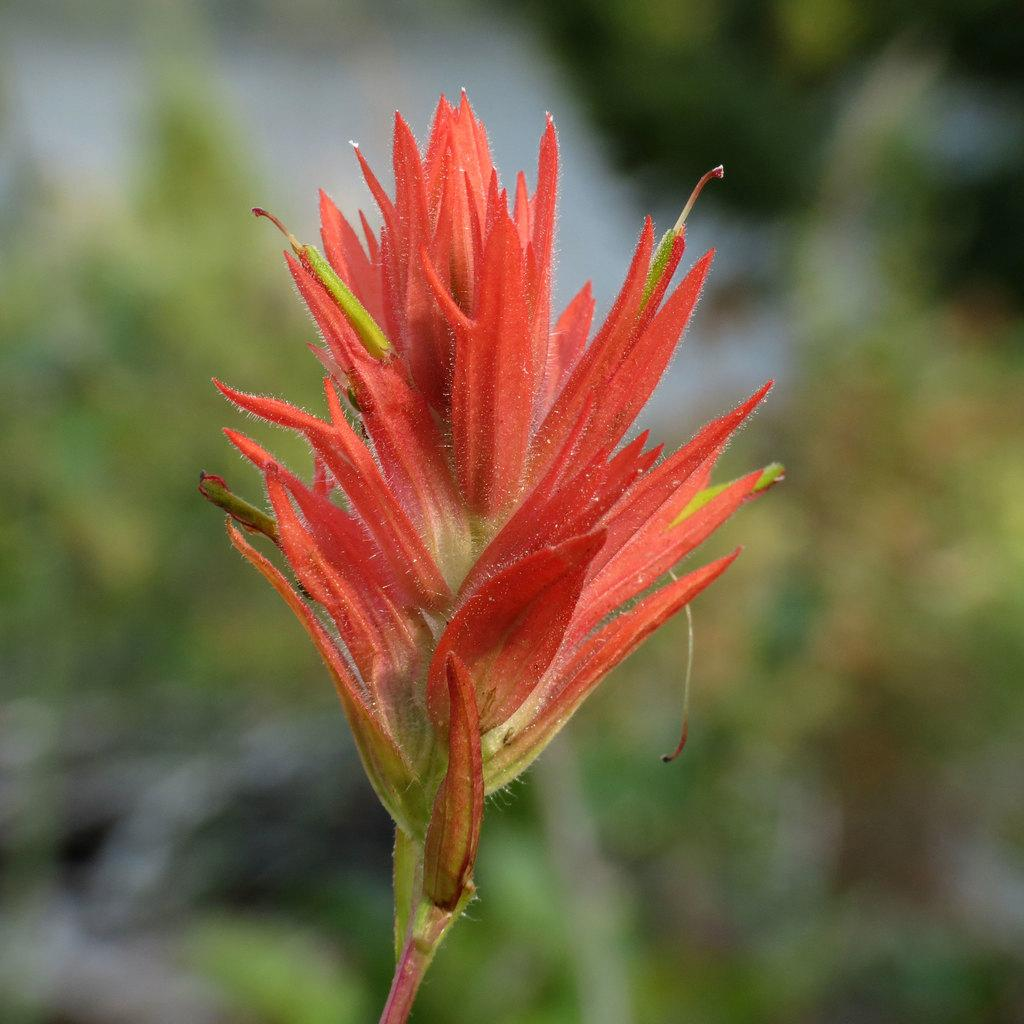What is the main subject of the image? There is a flower in the center of the image. Can you describe the flower in more detail? Unfortunately, the facts provided do not give any additional details about the flower. Is there anything else in the image besides the flower? The facts provided do not mention any other objects or subjects in the image. How many toes does the robin have in the image? There is no robin present in the image, so it is not possible to determine the number of toes it might have. 